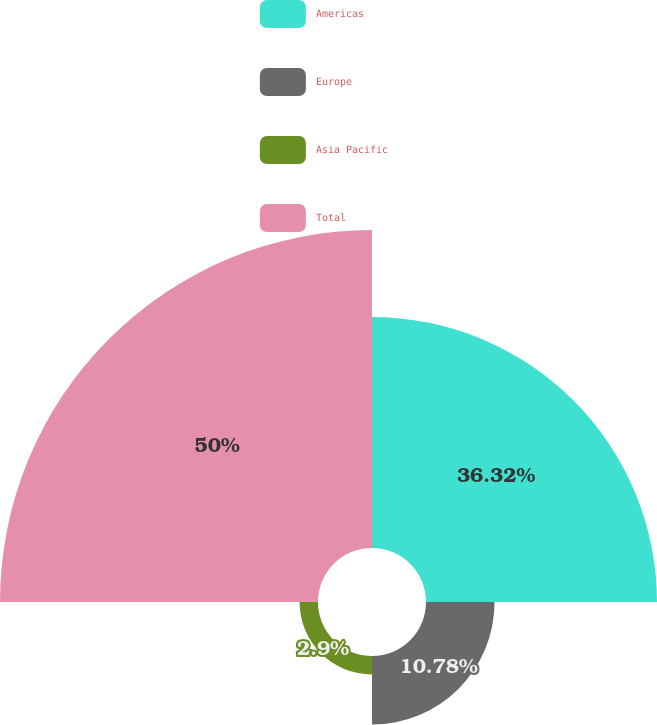Convert chart. <chart><loc_0><loc_0><loc_500><loc_500><pie_chart><fcel>Americas<fcel>Europe<fcel>Asia Pacific<fcel>Total<nl><fcel>36.32%<fcel>10.78%<fcel>2.9%<fcel>50.0%<nl></chart> 